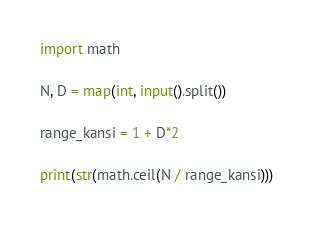Convert code to text. <code><loc_0><loc_0><loc_500><loc_500><_Python_>import math

N, D = map(int, input().split())

range_kansi = 1 + D*2 

print(str(math.ceil(N / range_kansi)))</code> 